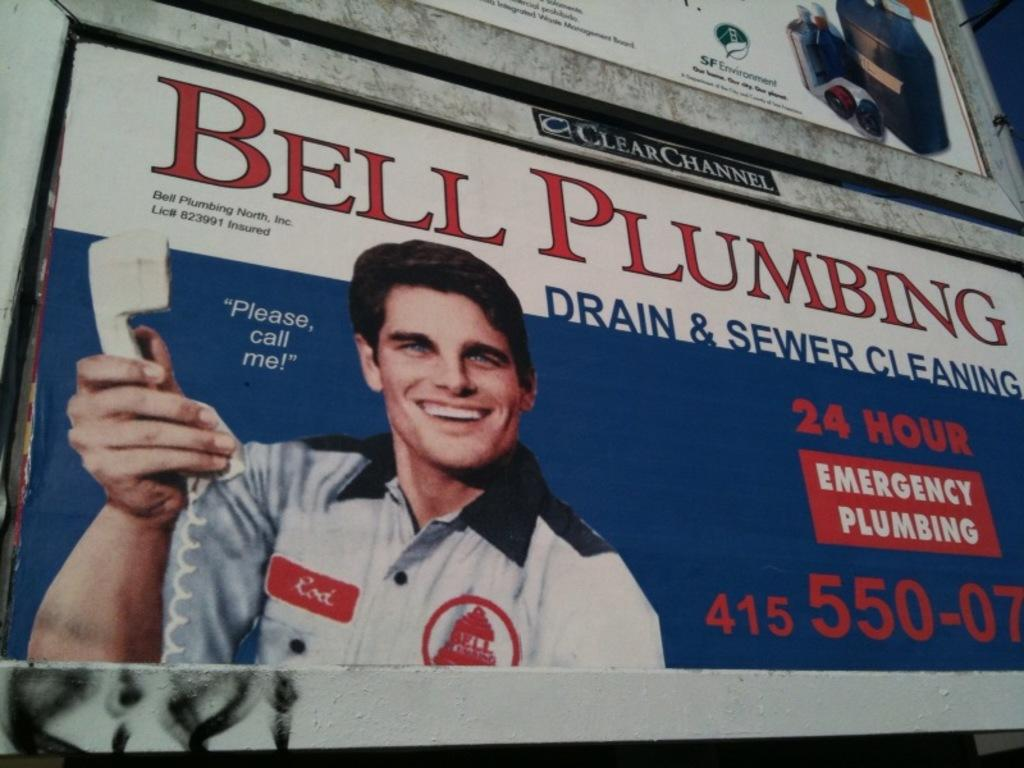What is present in the image that is used for advertising? There are hoardings in the image that are used for advertising. Who is featured on the hoarding? A man is depicted on the hoarding. What is the man holding in the image? The man is holding a telephone in the image. What type of pencil can be seen in the man's hand in the image? There is no pencil present in the image; the man is holding a telephone. Is there a camp visible in the background of the image? There is no camp present in the image; it only features a man on a hoarding. 